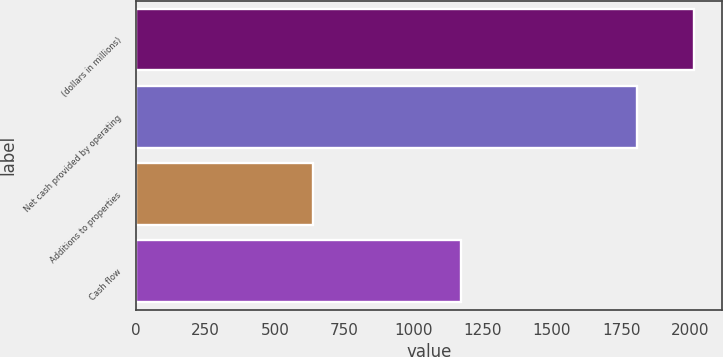<chart> <loc_0><loc_0><loc_500><loc_500><bar_chart><fcel>(dollars in millions)<fcel>Net cash provided by operating<fcel>Additions to properties<fcel>Cash flow<nl><fcel>2013<fcel>1807<fcel>637<fcel>1170<nl></chart> 